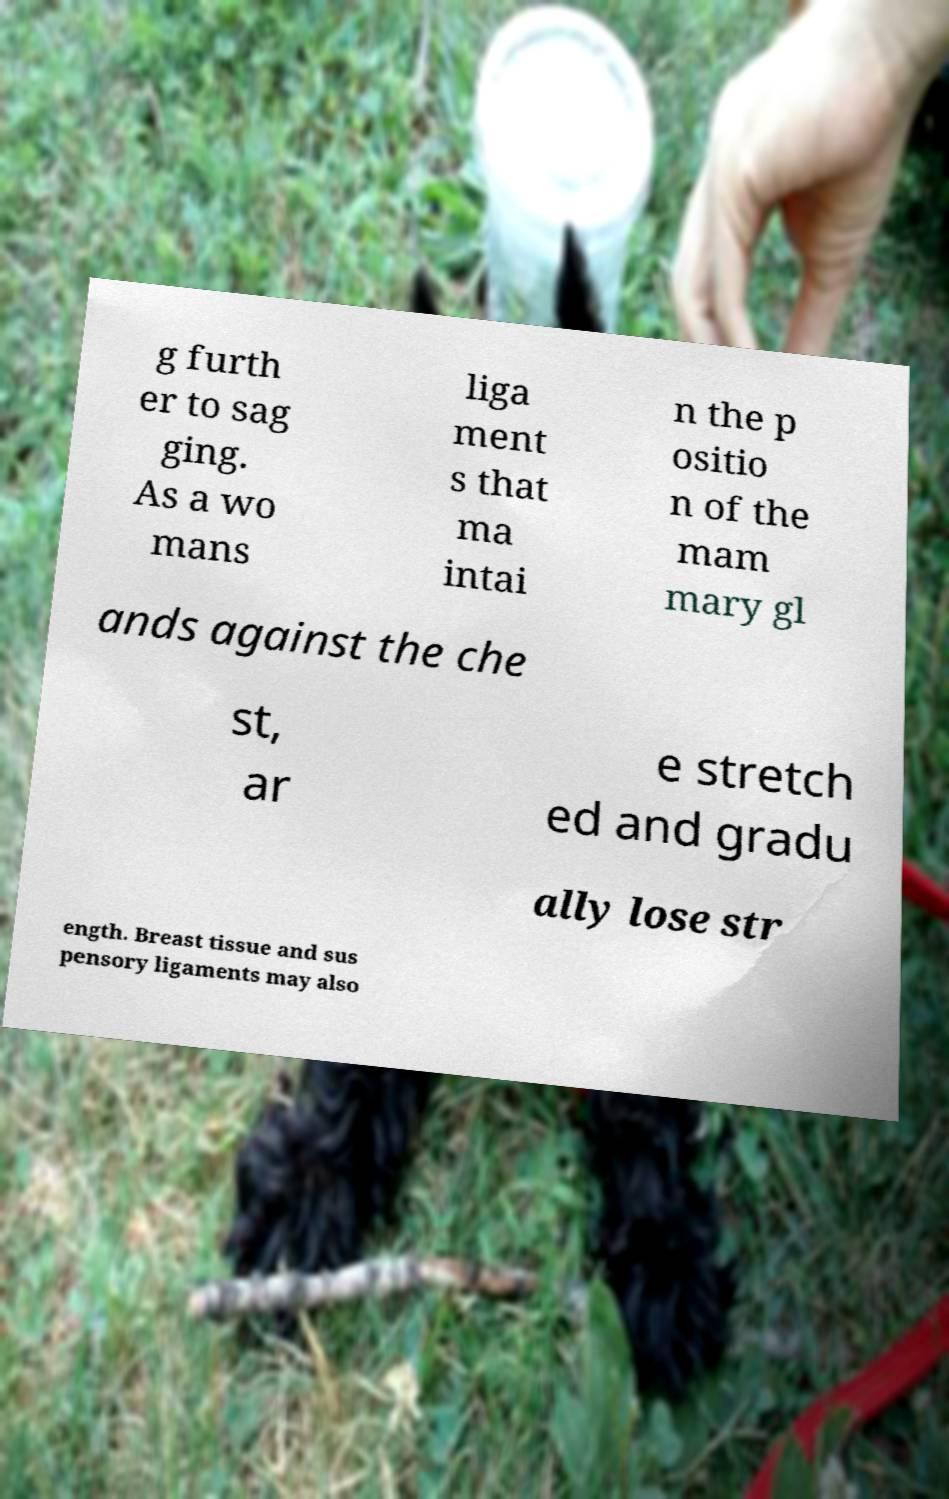Please identify and transcribe the text found in this image. g furth er to sag ging. As a wo mans liga ment s that ma intai n the p ositio n of the mam mary gl ands against the che st, ar e stretch ed and gradu ally lose str ength. Breast tissue and sus pensory ligaments may also 